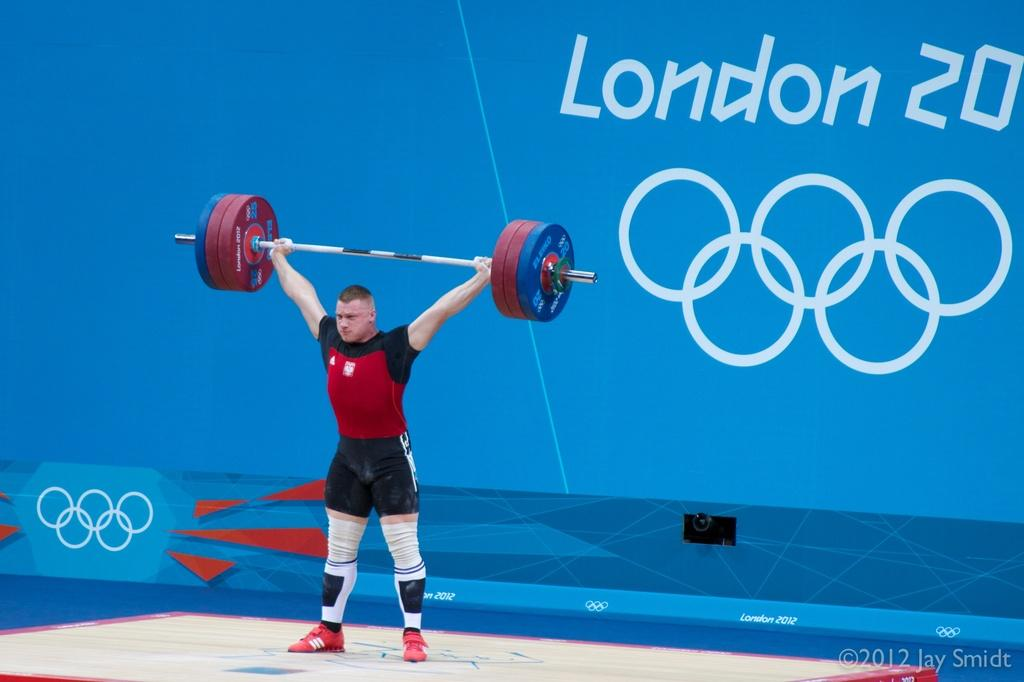What is the man in the image doing? The man is lifting weight in the image. What can be seen in the background of the image? There is a blue color wall in the background. What is written or depicted on the wall? The wall has text and a design on it. How many straws are on the man's head in the image? There are no straws present on the man's head in the image. What type of owl can be seen perched on the weight in the image? There is no owl present in the image; the man is lifting a weight without any additional objects or animals. 